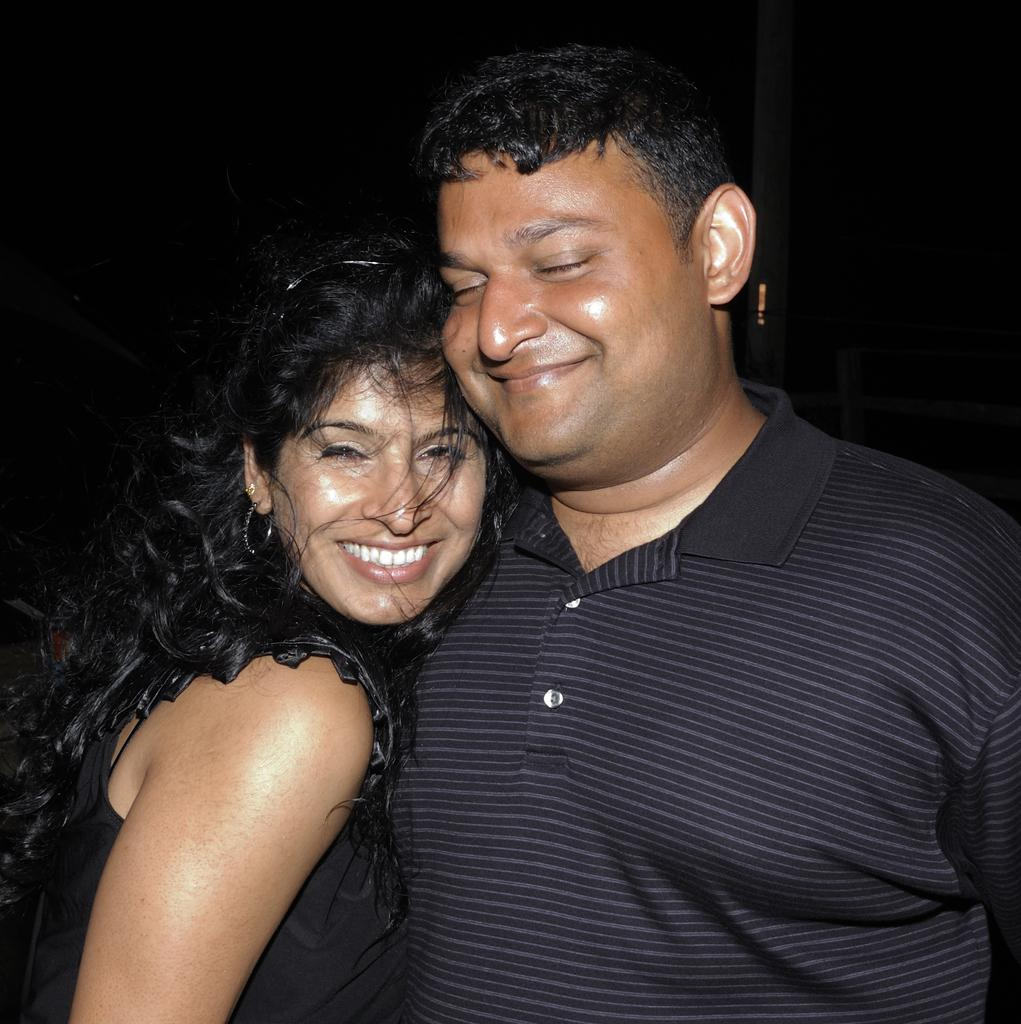How many people are in the image? There are two persons in the image. What is one person wearing? One person is wearing a black t-shirt. What is the other person wearing? One woman is wearing a black dress. What type of railway is visible in the image? There is no railway present in the image. What property is being discussed in the image? The image does not depict a discussion about any property. 